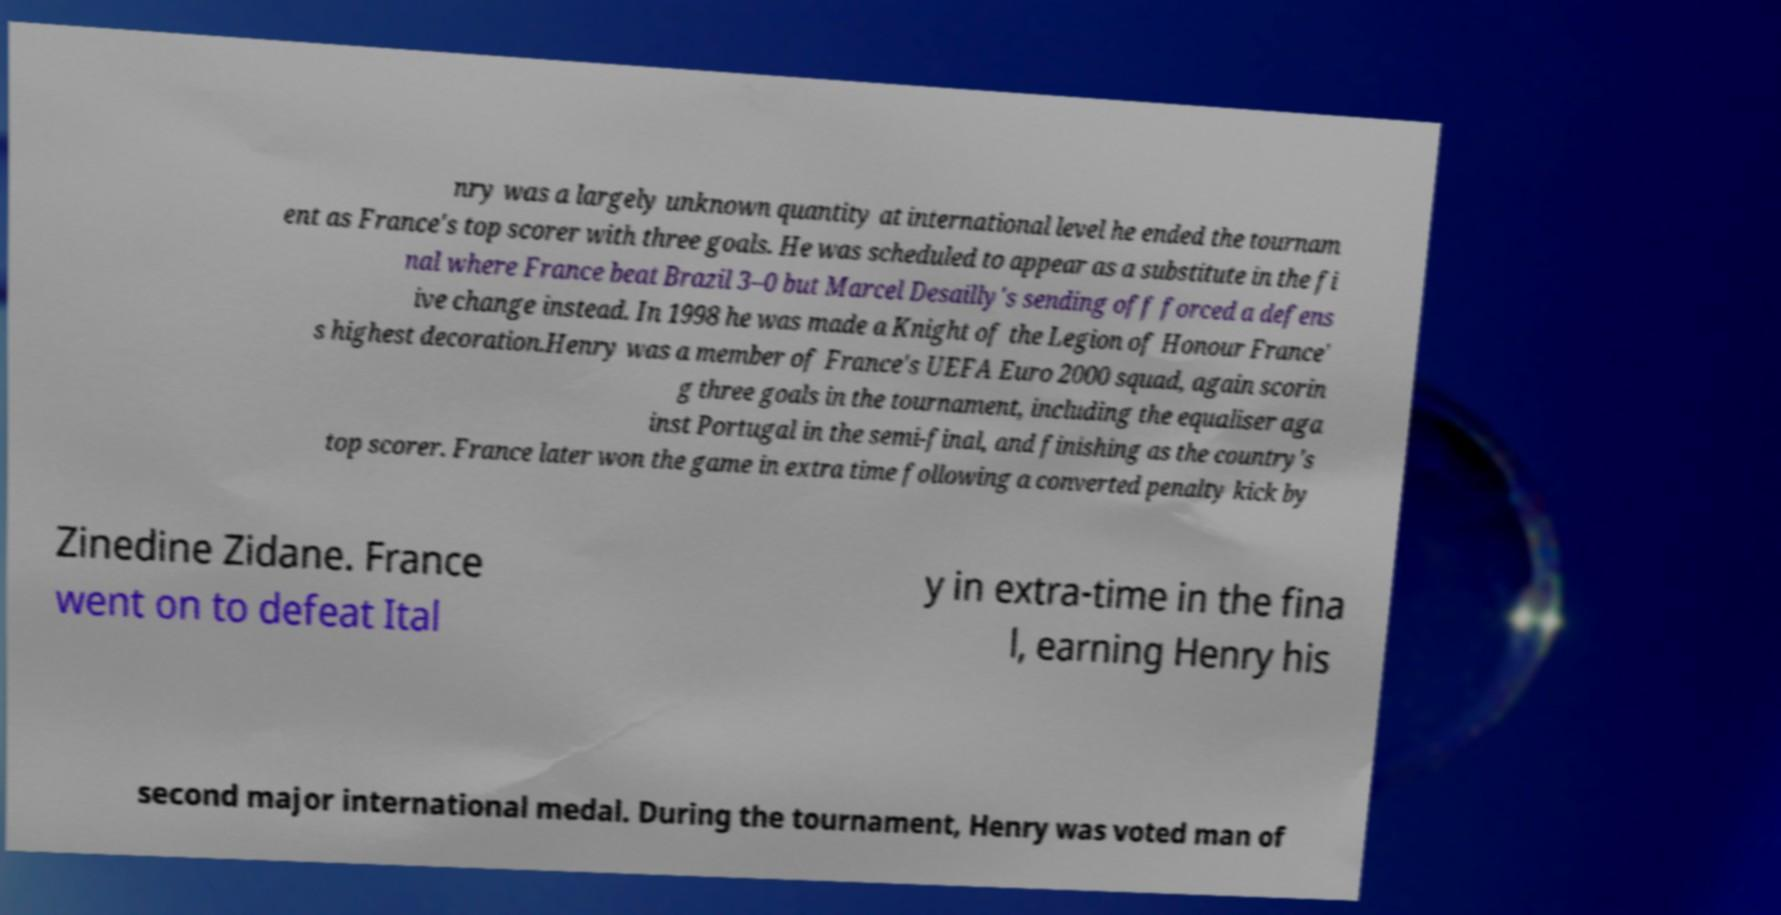Please read and relay the text visible in this image. What does it say? nry was a largely unknown quantity at international level he ended the tournam ent as France's top scorer with three goals. He was scheduled to appear as a substitute in the fi nal where France beat Brazil 3–0 but Marcel Desailly's sending off forced a defens ive change instead. In 1998 he was made a Knight of the Legion of Honour France' s highest decoration.Henry was a member of France's UEFA Euro 2000 squad, again scorin g three goals in the tournament, including the equaliser aga inst Portugal in the semi-final, and finishing as the country's top scorer. France later won the game in extra time following a converted penalty kick by Zinedine Zidane. France went on to defeat Ital y in extra-time in the fina l, earning Henry his second major international medal. During the tournament, Henry was voted man of 